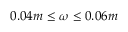Convert formula to latex. <formula><loc_0><loc_0><loc_500><loc_500>0 . 0 4 m \leq \omega \leq 0 . 0 6 m</formula> 